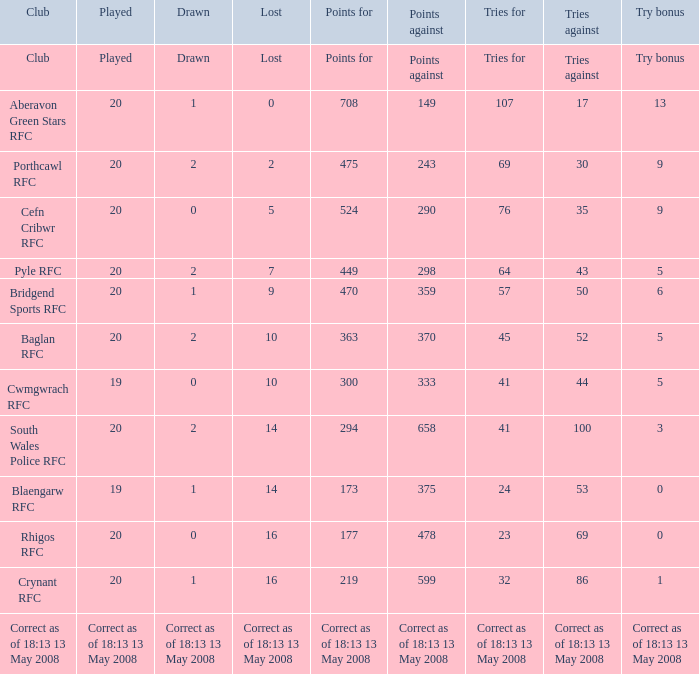What is the loss when the try bonus is 5 and the points against are 298? 7.0. 